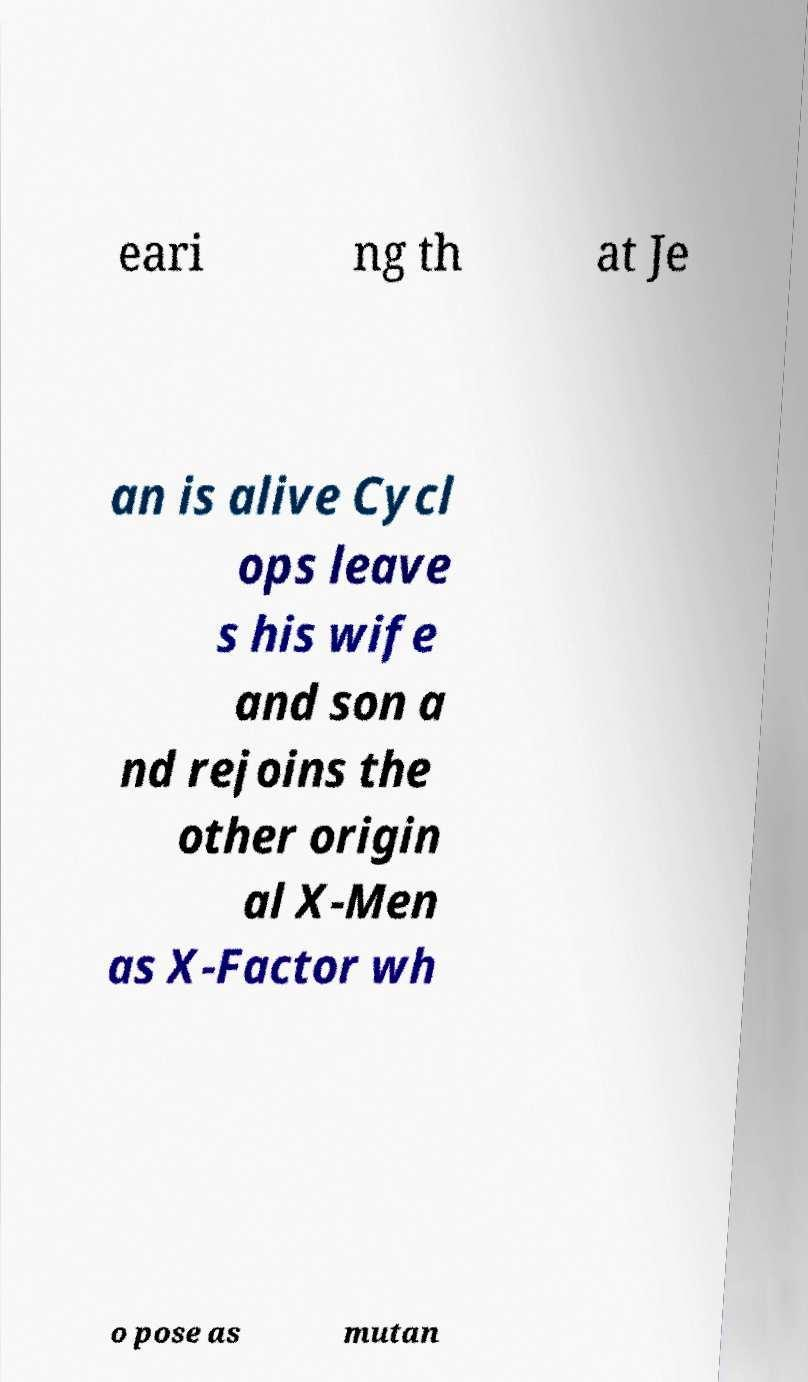What messages or text are displayed in this image? I need them in a readable, typed format. eari ng th at Je an is alive Cycl ops leave s his wife and son a nd rejoins the other origin al X-Men as X-Factor wh o pose as mutan 